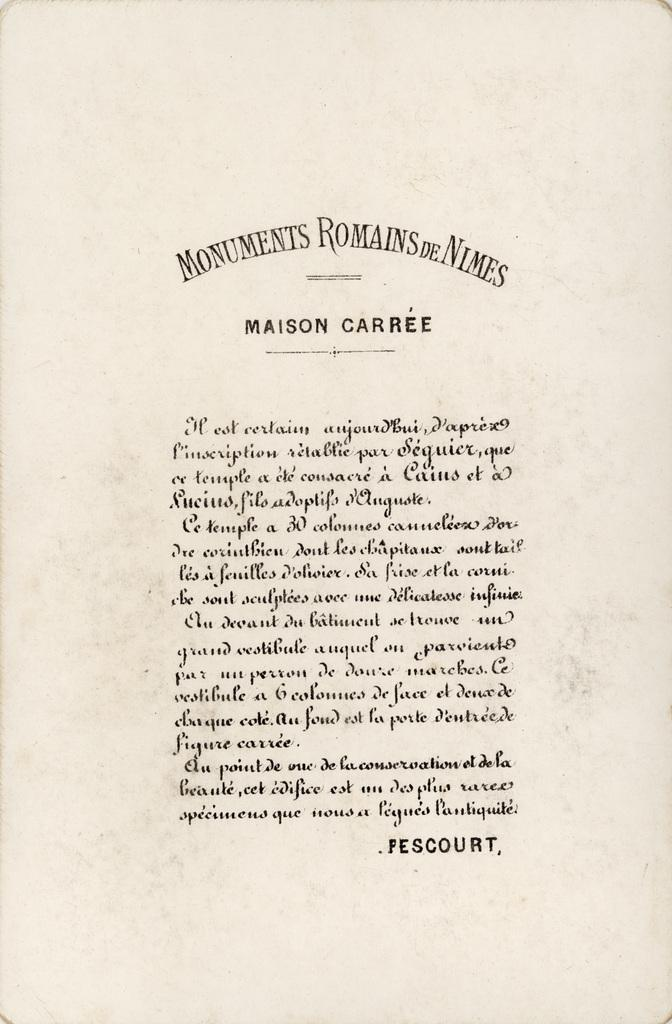<image>
Create a compact narrative representing the image presented. a sheet of paper that says Monuments at the top 